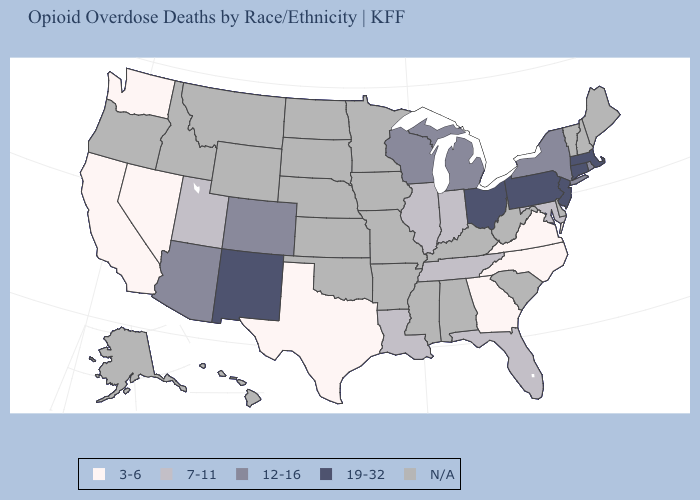Among the states that border New Jersey , which have the highest value?
Give a very brief answer. Pennsylvania. What is the lowest value in the Northeast?
Answer briefly. 12-16. What is the value of Idaho?
Keep it brief. N/A. Does the first symbol in the legend represent the smallest category?
Give a very brief answer. Yes. What is the lowest value in states that border Nevada?
Short answer required. 3-6. What is the value of New Jersey?
Be succinct. 19-32. Which states hav the highest value in the South?
Keep it brief. Florida, Louisiana, Maryland, Tennessee. What is the value of Florida?
Be succinct. 7-11. What is the value of New Hampshire?
Answer briefly. N/A. What is the value of New York?
Write a very short answer. 12-16. Name the states that have a value in the range N/A?
Give a very brief answer. Alabama, Alaska, Arkansas, Delaware, Hawaii, Idaho, Iowa, Kansas, Kentucky, Maine, Minnesota, Mississippi, Missouri, Montana, Nebraska, New Hampshire, North Dakota, Oklahoma, Oregon, South Carolina, South Dakota, Vermont, West Virginia, Wyoming. Is the legend a continuous bar?
Write a very short answer. No. Name the states that have a value in the range 19-32?
Answer briefly. Connecticut, Massachusetts, New Jersey, New Mexico, Ohio, Pennsylvania. Which states hav the highest value in the MidWest?
Write a very short answer. Ohio. 